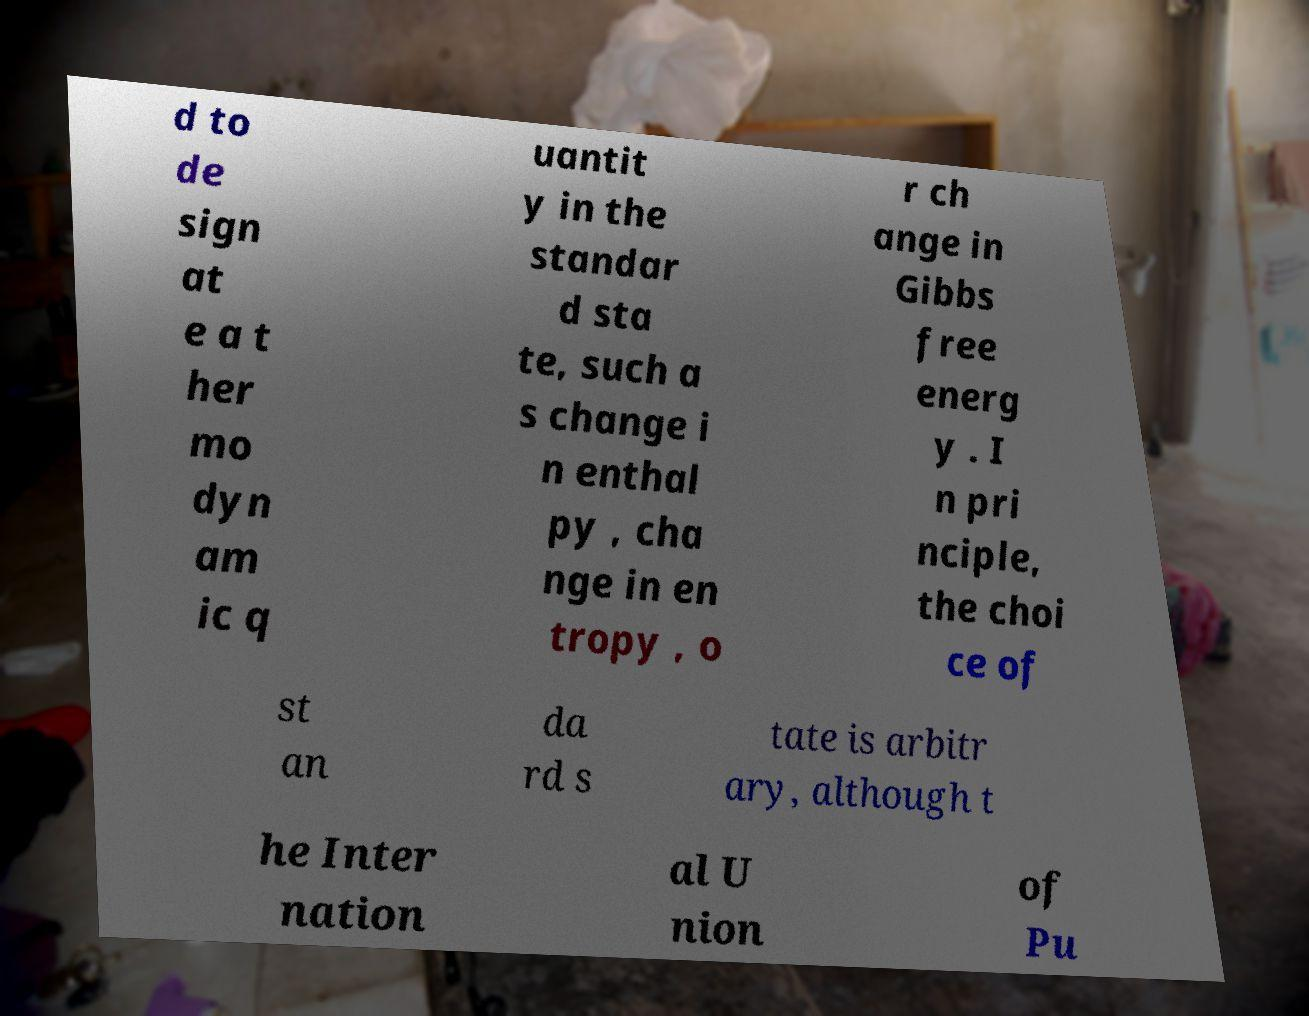Could you extract and type out the text from this image? d to de sign at e a t her mo dyn am ic q uantit y in the standar d sta te, such a s change i n enthal py , cha nge in en tropy , o r ch ange in Gibbs free energ y . I n pri nciple, the choi ce of st an da rd s tate is arbitr ary, although t he Inter nation al U nion of Pu 